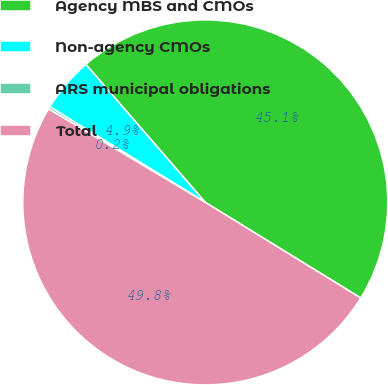<chart> <loc_0><loc_0><loc_500><loc_500><pie_chart><fcel>Agency MBS and CMOs<fcel>Non-agency CMOs<fcel>ARS municipal obligations<fcel>Total<nl><fcel>45.13%<fcel>4.87%<fcel>0.22%<fcel>49.78%<nl></chart> 